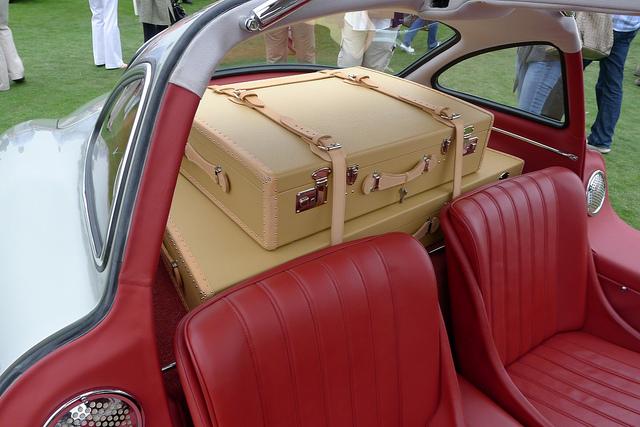What color is the car interior?
Keep it brief. Red. Are there leather straps around the suitcases?
Short answer required. Yes. Are there people standing around the car?
Be succinct. Yes. 